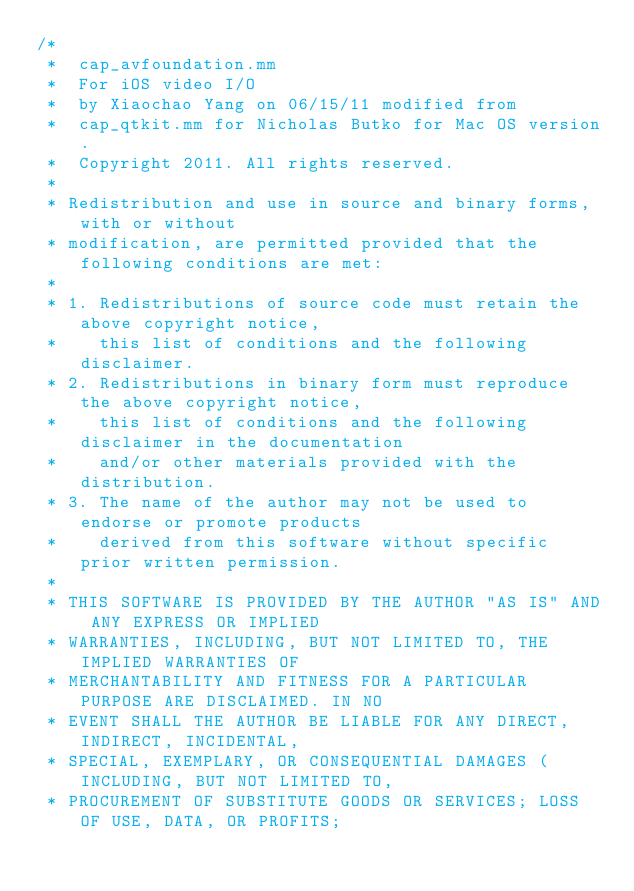Convert code to text. <code><loc_0><loc_0><loc_500><loc_500><_ObjectiveC_>/*
 *  cap_avfoundation.mm
 *  For iOS video I/O
 *  by Xiaochao Yang on 06/15/11 modified from
 *  cap_qtkit.mm for Nicholas Butko for Mac OS version.
 *  Copyright 2011. All rights reserved.
 *
 * Redistribution and use in source and binary forms, with or without
 * modification, are permitted provided that the following conditions are met:
 *
 * 1. Redistributions of source code must retain the above copyright notice,
 *    this list of conditions and the following disclaimer.
 * 2. Redistributions in binary form must reproduce the above copyright notice,
 *    this list of conditions and the following disclaimer in the documentation
 *    and/or other materials provided with the distribution.
 * 3. The name of the author may not be used to endorse or promote products
 *    derived from this software without specific prior written permission.
 *
 * THIS SOFTWARE IS PROVIDED BY THE AUTHOR "AS IS" AND ANY EXPRESS OR IMPLIED
 * WARRANTIES, INCLUDING, BUT NOT LIMITED TO, THE IMPLIED WARRANTIES OF
 * MERCHANTABILITY AND FITNESS FOR A PARTICULAR PURPOSE ARE DISCLAIMED. IN NO
 * EVENT SHALL THE AUTHOR BE LIABLE FOR ANY DIRECT, INDIRECT, INCIDENTAL,
 * SPECIAL, EXEMPLARY, OR CONSEQUENTIAL DAMAGES (INCLUDING, BUT NOT LIMITED TO,
 * PROCUREMENT OF SUBSTITUTE GOODS OR SERVICES; LOSS OF USE, DATA, OR PROFITS;</code> 